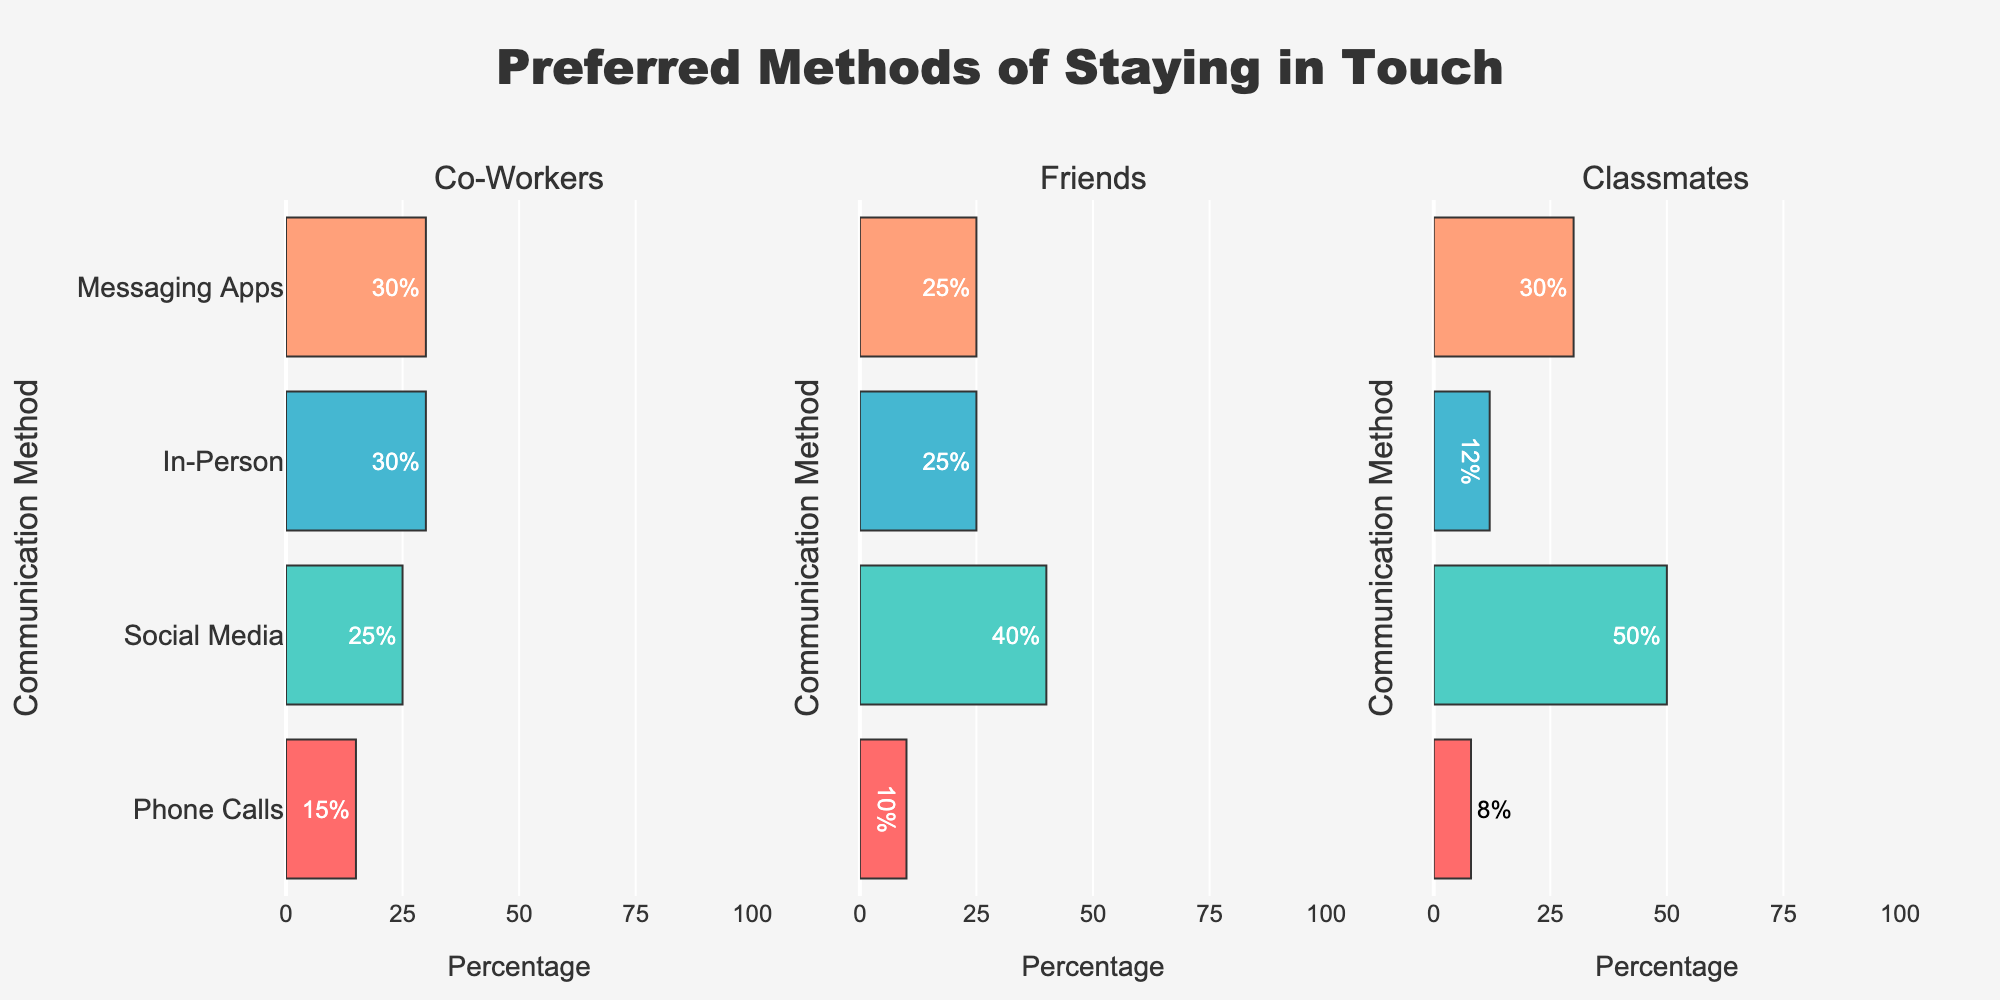What is the most preferred method of staying in touch with classmates? The group "Classmates" shows the highest percentage for the "Social Media" method at 50%.
Answer: Social Media Which social group uses phone calls the least to stay in touch? Comparing the "Phone Calls" bars across all social groups, the "Classmates" group has the lowest percentage at 8%.
Answer: Classmates What percentage of co-workers prefer messaging apps? The bar for "Messaging Apps" in the "Co-Workers" group shows a percentage of 30%.
Answer: 30% Which communication method is most popular among friends? The "Friends" group has the highest percentage for the "Social Media" method at 40%.
Answer: Social Media How much more popular are in-person meetups with co-workers compared to classmates? For "Co-Workers", the percentage for "In-Person" is 30%, and for "Classmates", it is 12%. The difference is 30% - 12% = 18%.
Answer: 18% Compare the preference for social media between friends and classmates. The "Social Media" bar for "Friends" is 40%, and for "Classmates", it is 50%. The "Classmates" group prefers social media more.
Answer: Classmates What is the combined percentage of co-workers that prefer in-person or messaging apps? The "Co-Workers" group shows 30% for "In-Person" and 30% for "Messaging Apps". Combined, it is 30% + 30% = 60%.
Answer: 60% Which method has the lowest percentage for staying in touch with friends? The "Phone Calls" method for the "Friends" group has the lowest percentage at 10%.
Answer: Phone Calls What is the average percentage of social media preference across all social groups? The percentages for "Social Media" are 25% (Co-Workers), 40% (Friends), and 50% (Classmates). The average is (25 + 40 + 50) / 3 = 38.33%.
Answer: 38.33% What is the color of the bar representing the highest percentage method for classmates? The bar with the highest percentage (50%) for "Classmates" corresponds to "Social Media" and is depicted in blue.
Answer: Blue 